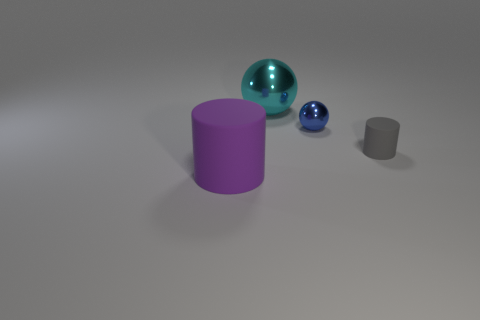Add 3 big purple cylinders. How many objects exist? 7 Subtract all gray cylinders. How many cylinders are left? 1 Subtract 1 cylinders. How many cylinders are left? 1 Add 3 cylinders. How many cylinders exist? 5 Subtract 0 green cylinders. How many objects are left? 4 Subtract all blue cylinders. Subtract all red balls. How many cylinders are left? 2 Subtract all small cyan balls. Subtract all cylinders. How many objects are left? 2 Add 2 cyan objects. How many cyan objects are left? 3 